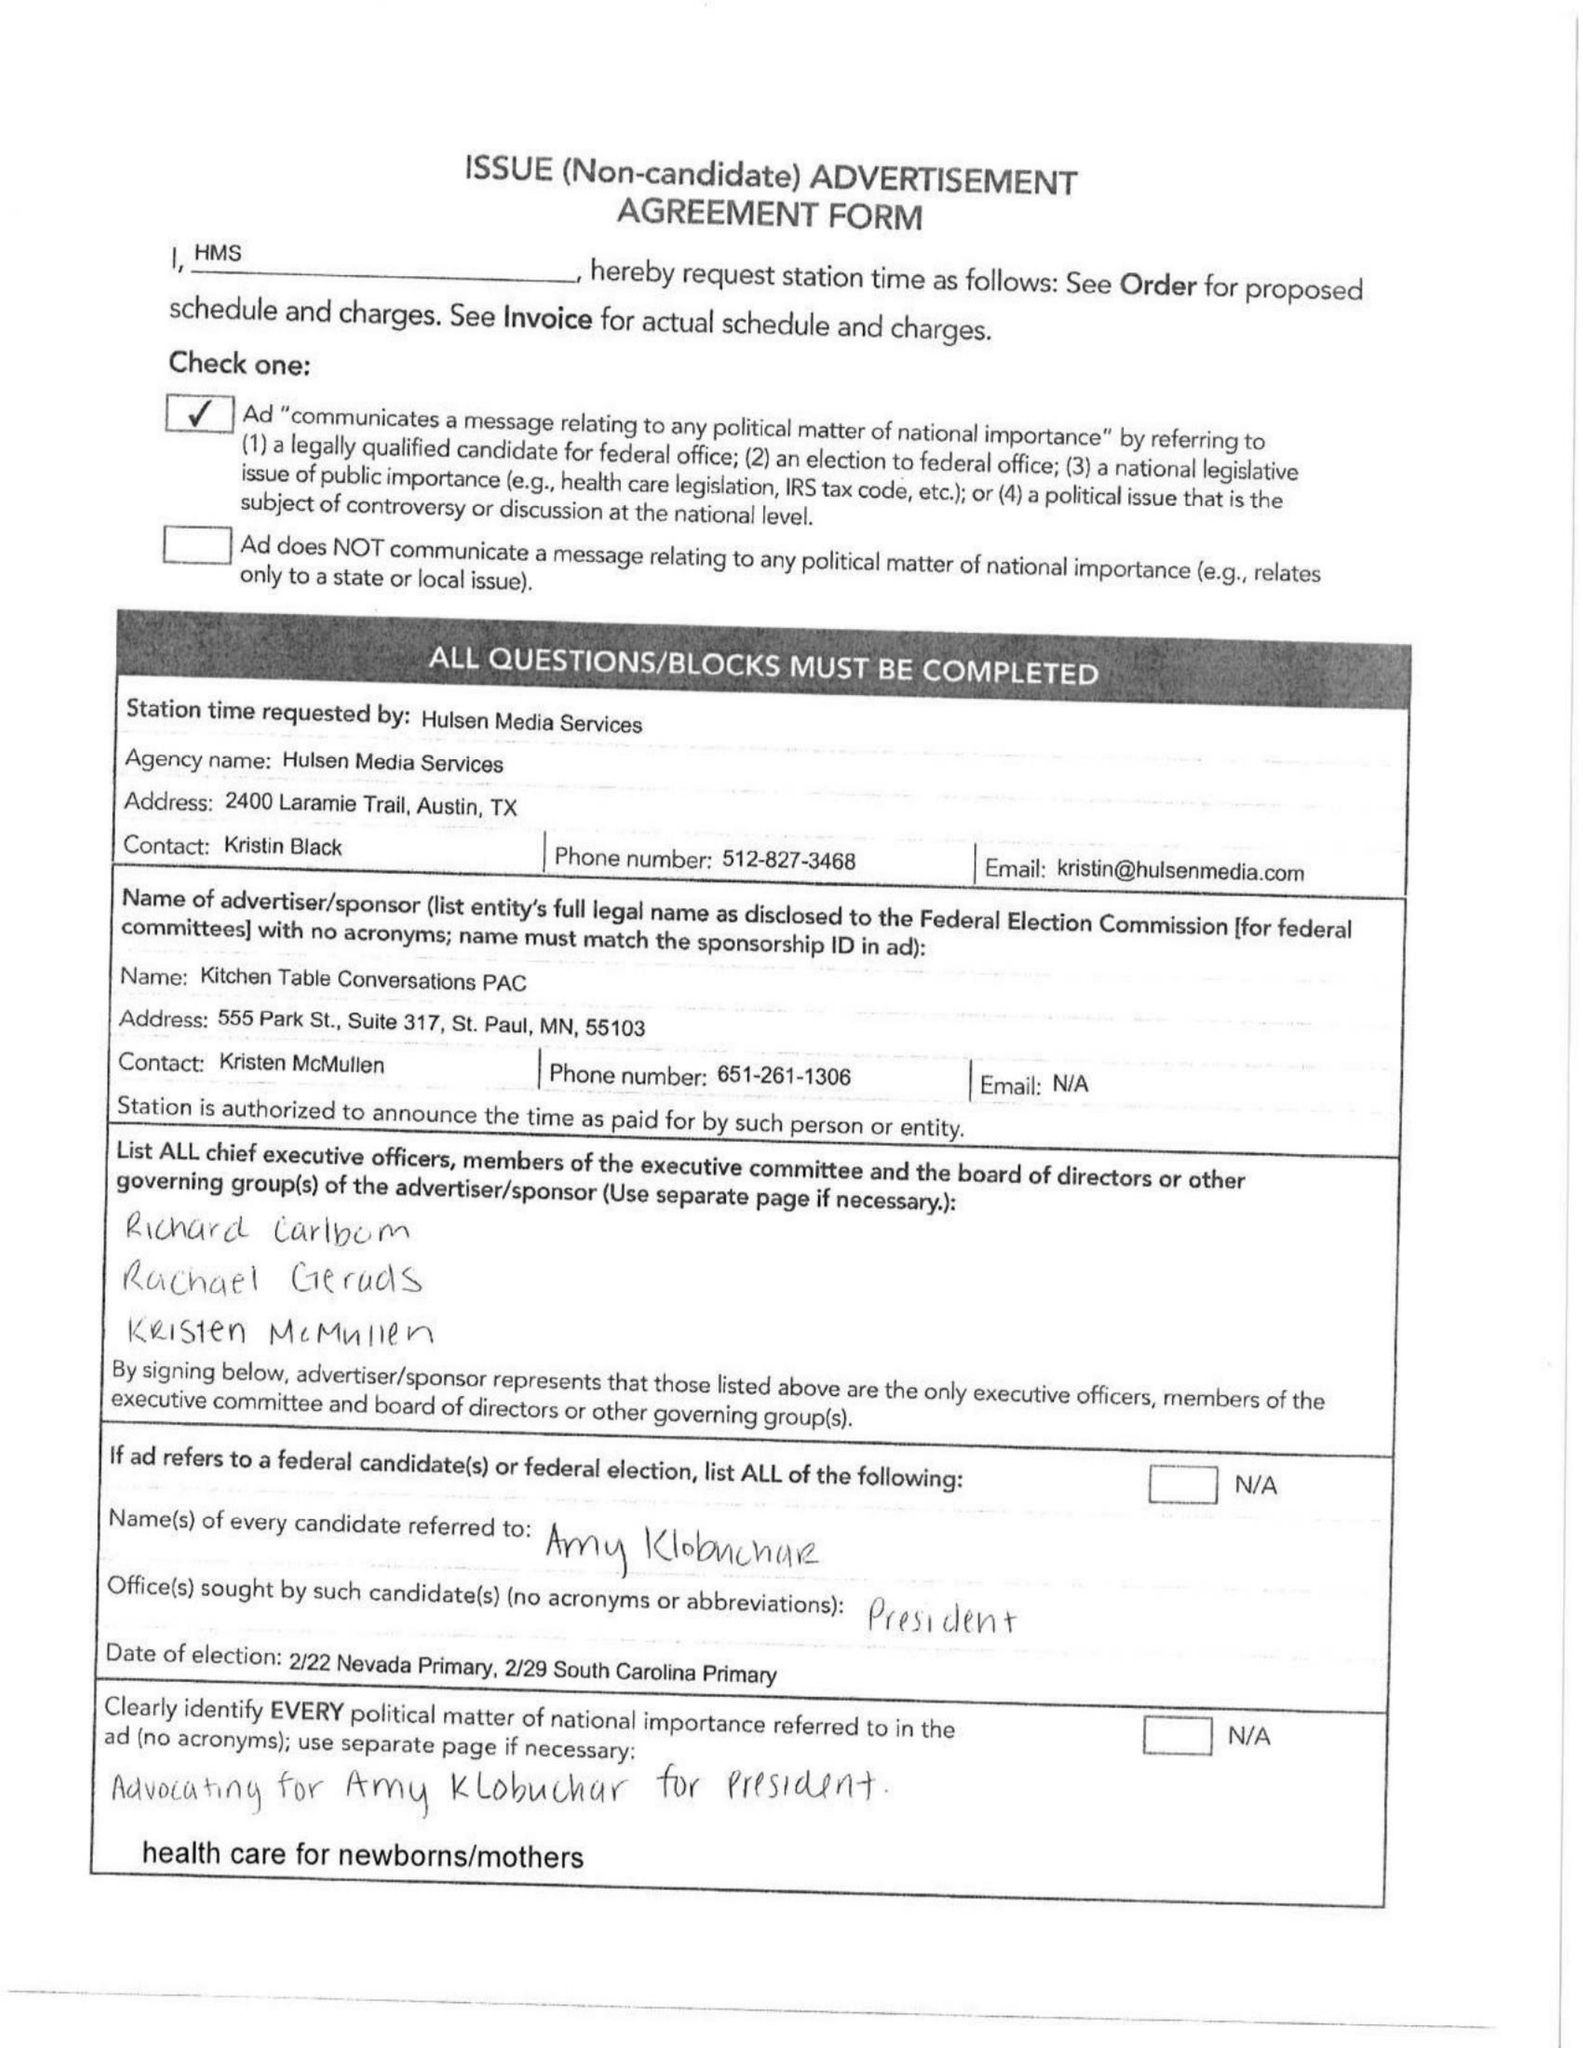What is the value for the gross_amount?
Answer the question using a single word or phrase. None 